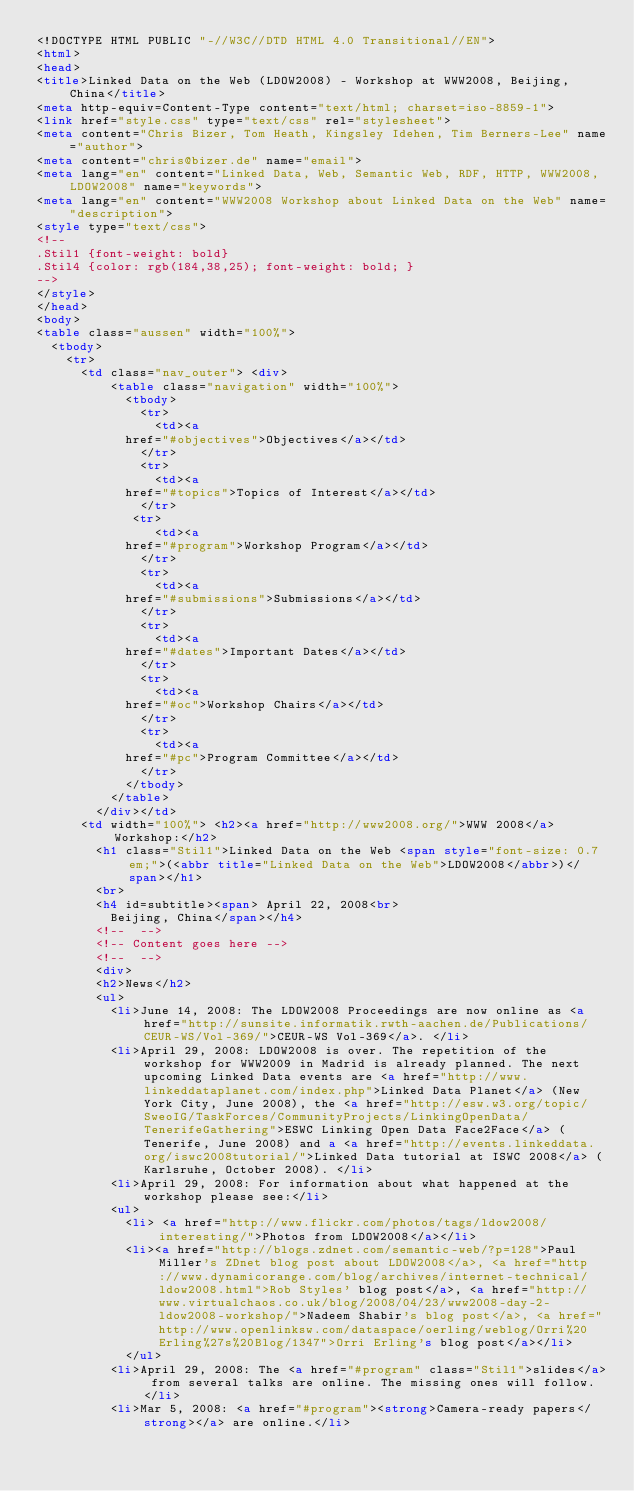Convert code to text. <code><loc_0><loc_0><loc_500><loc_500><_HTML_><!DOCTYPE HTML PUBLIC "-//W3C//DTD HTML 4.0 Transitional//EN">
<html>
<head>
<title>Linked Data on the Web (LDOW2008) - Workshop at WWW2008, Beijing, China</title>
<meta http-equiv=Content-Type content="text/html; charset=iso-8859-1">
<link href="style.css" type="text/css" rel="stylesheet">
<meta content="Chris Bizer, Tom Heath, Kingsley Idehen, Tim Berners-Lee" name="author">
<meta content="chris@bizer.de" name="email">
<meta lang="en" content="Linked Data, Web, Semantic Web, RDF, HTTP, WWW2008, LDOW2008" name="keywords">
<meta lang="en" content="WWW2008 Workshop about Linked Data on the Web" name="description">
<style type="text/css">
<!--
.Stil1 {font-weight: bold}
.Stil4 {color: rgb(184,38,25); font-weight: bold; }
-->
</style>
</head>
<body> 
<table class="aussen" width="100%"> 
  <tbody> 
    <tr> 
      <td class="nav_outer"> <div> 
          <table class="navigation" width="100%"> 
            <tbody> 
              <tr> 
                <td><a 
            href="#objectives">Objectives</a></td> 
              </tr> 
              <tr> 
                <td><a 
            href="#topics">Topics of Interest</a></td> 
              </tr> 
			 <tr> 
                <td><a 
            href="#program">Workshop Program</a></td> 
              </tr> 
              <tr> 
                <td><a 
            href="#submissions">Submissions</a></td> 
              </tr> 
              <tr> 
                <td><a 
            href="#dates">Important Dates</a></td> 
              </tr> 
              <tr> 
                <td><a 
            href="#oc">Workshop Chairs</a></td> 
              </tr> 
              <tr> 
                <td><a 
            href="#pc">Program Committee</a></td> 
              </tr> 
            </tbody> 
          </table> 
        </div></td> 
      <td width="100%"> <h2><a href="http://www2008.org/">WWW 2008</a> Workshop:</h2> 
        <h1 class="Stil1">Linked Data on the Web <span style="font-size: 0.7em;">(<abbr title="Linked Data on the Web">LDOW2008</abbr>)</span></h1> 
        <br> 
        <h4 id=subtitle><span> April 22, 2008<br> 
          Beijing, China</span></h4> 
        <!--  --> 
        <!-- Content goes here --> 
        <!--  --> 
        <div>
	    <h2>News</h2>
	    <ul>
	      <li>June 14, 2008: The LDOW2008 Proceedings are now online as <a href="http://sunsite.informatik.rwth-aachen.de/Publications/CEUR-WS/Vol-369/">CEUR-WS Vol-369</a>. </li>
	      <li>April 29, 2008: LDOW2008 is over. The repetition of the workshop for WWW2009 in Madrid is already planned. The next upcoming Linked Data events are <a href="http://www.linkeddataplanet.com/index.php">Linked Data Planet</a> (New York City, June 2008), the <a href="http://esw.w3.org/topic/SweoIG/TaskForces/CommunityProjects/LinkingOpenData/TenerifeGathering">ESWC Linking Open Data Face2Face</a> (Tenerife, June 2008) and a <a href="http://events.linkeddata.org/iswc2008tutorial/">Linked Data tutorial at ISWC 2008</a> (Karlsruhe, October 2008). </li>
	      <li>April 29, 2008: For information about what happened at the workshop please see:</li>
	      <ul>
		    <li> <a href="http://www.flickr.com/photos/tags/ldow2008/interesting/">Photos from LDOW2008</a></li>
		    <li><a href="http://blogs.zdnet.com/semantic-web/?p=128">Paul Miller's ZDnet blog post about LDOW2008</a>, <a href="http://www.dynamicorange.com/blog/archives/internet-technical/ldow2008.html">Rob Styles' blog post</a>, <a href="http://www.virtualchaos.co.uk/blog/2008/04/23/www2008-day-2-ldow2008-workshop/">Nadeem Shabir's blog post</a>, <a href="http://www.openlinksw.com/dataspace/oerling/weblog/Orri%20Erling%27s%20Blog/1347">Orri Erling's blog post</a></li>
		    </ul>
	      <li>April 29, 2008: The <a href="#program" class="Stil1">slides</a> from several talks are online. The missing ones will follow. </li>
	      <li>Mar 5, 2008: <a href="#program"><strong>Camera-ready papers</strong></a> are online.</li></code> 